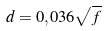Convert formula to latex. <formula><loc_0><loc_0><loc_500><loc_500>d = 0 , 0 3 6 \sqrt { f }</formula> 